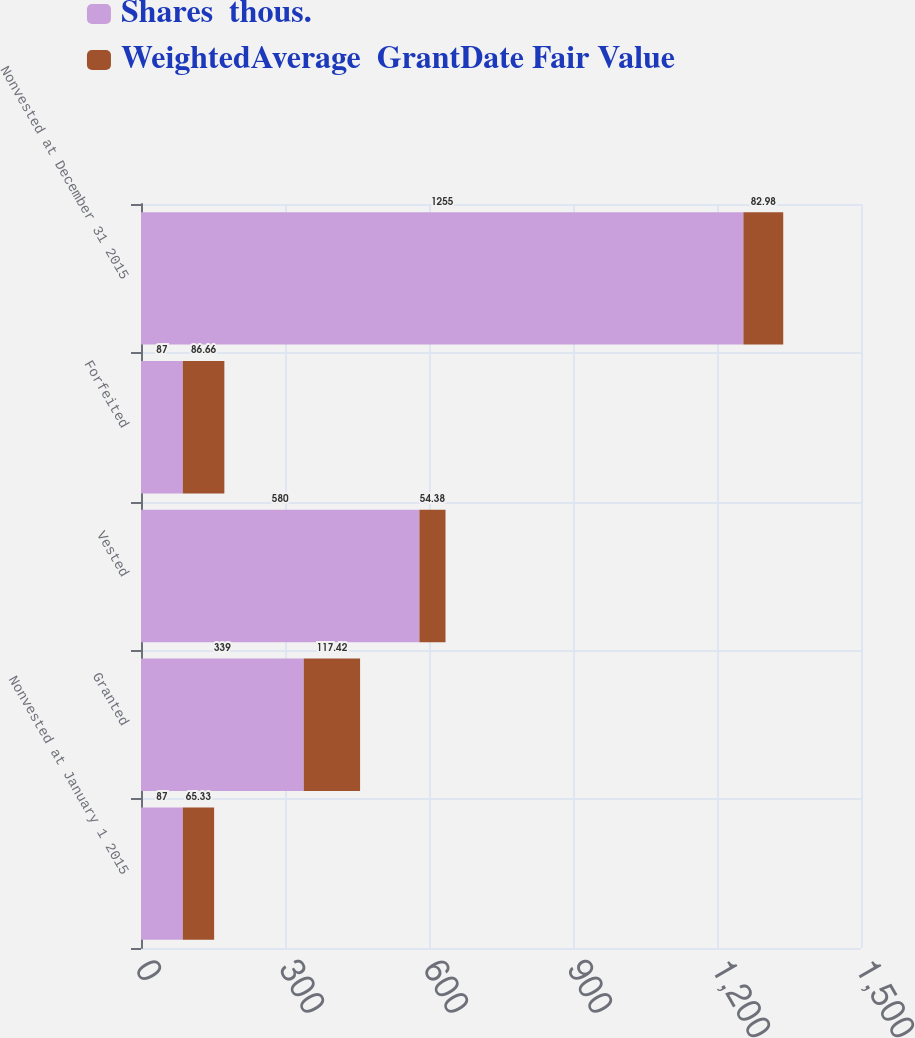<chart> <loc_0><loc_0><loc_500><loc_500><stacked_bar_chart><ecel><fcel>Nonvested at January 1 2015<fcel>Granted<fcel>Vested<fcel>Forfeited<fcel>Nonvested at December 31 2015<nl><fcel>Shares  thous.<fcel>87<fcel>339<fcel>580<fcel>87<fcel>1255<nl><fcel>WeightedAverage  GrantDate Fair Value<fcel>65.33<fcel>117.42<fcel>54.38<fcel>86.66<fcel>82.98<nl></chart> 